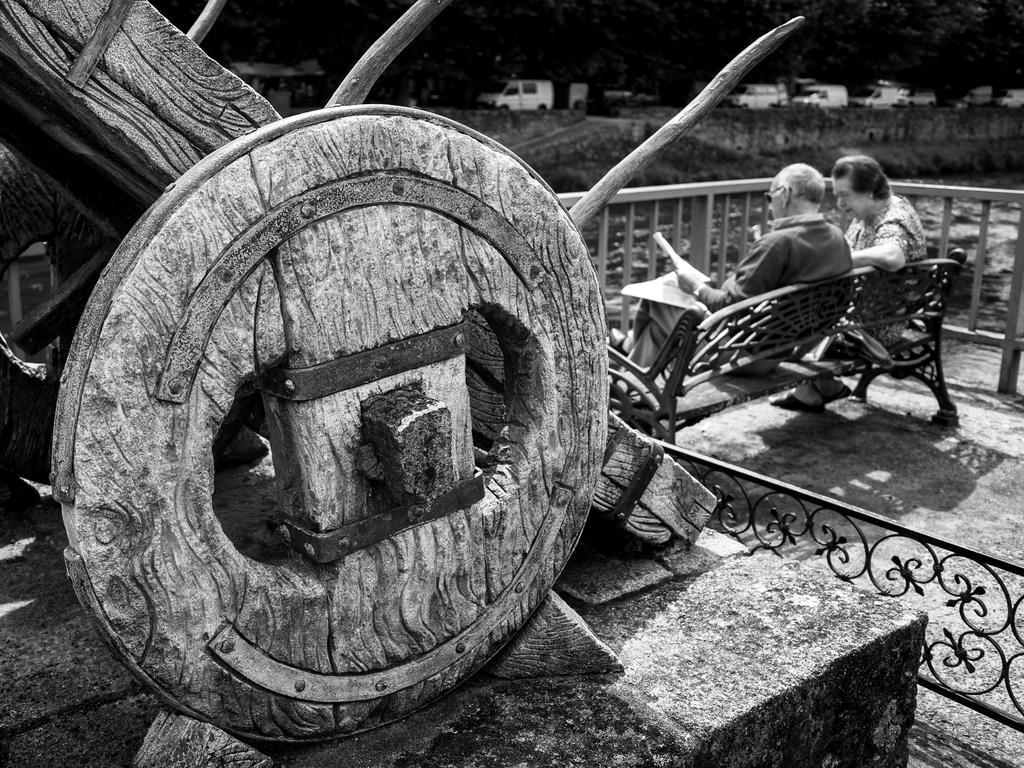Please provide a concise description of this image. This is the black and white picture of an old man and woman sitting on bench in front of fence, in the front there is wooden wheel, over the background there are few vehicles going on the road. 